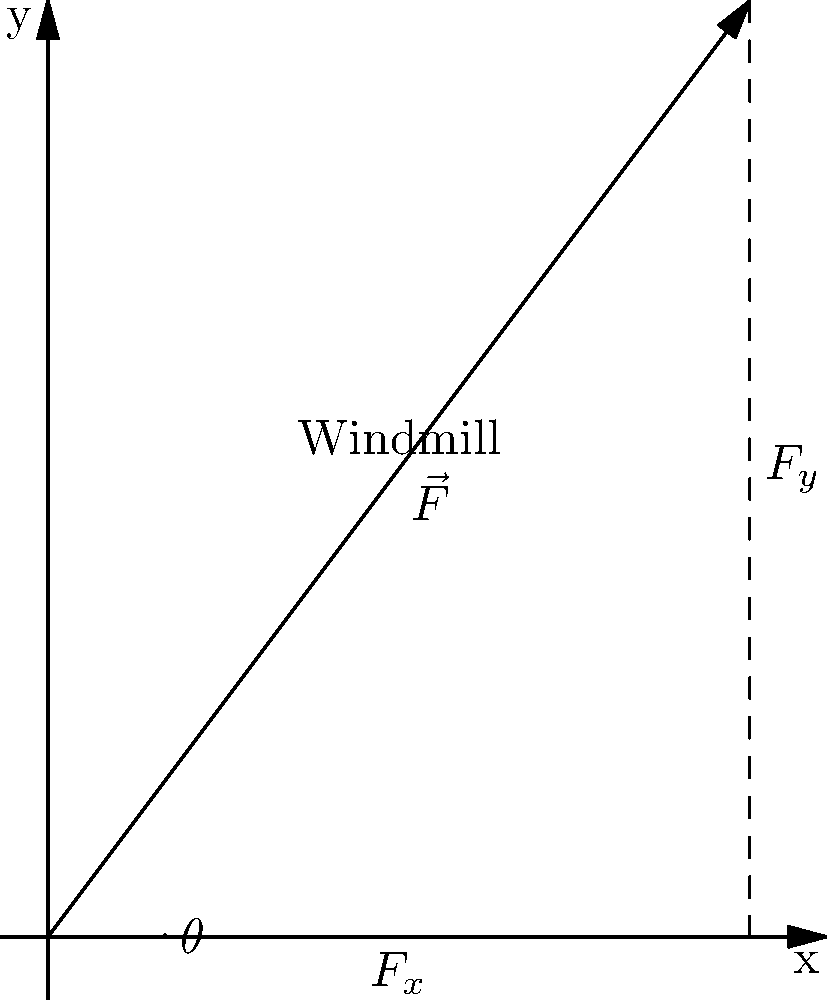In our historic Scanian windmill, the wind exerts a force $\vec{F}$ on the sails with a magnitude of 500 N at an angle of $53.13^\circ$ from the horizontal. What is the vertical component of this force, which contributes to the structural load on the windmill tower? To solve this problem, we'll use vector decomposition to find the vertical component of the force. Let's approach this step-by-step:

1) The force vector $\vec{F}$ can be decomposed into horizontal ($F_x$) and vertical ($F_y$) components.

2) We're interested in the vertical component $F_y$, which can be calculated using trigonometry:

   $F_y = |\vec{F}| \sin(\theta)$

3) We're given:
   - Magnitude of force $|\vec{F}| = 500$ N
   - Angle $\theta = 53.13^\circ$

4) Let's substitute these values:

   $F_y = 500 \sin(53.13^\circ)$

5) Using a calculator (or trigonometric tables, as they might have used in historical times):

   $\sin(53.13^\circ) \approx 0.8$

6) Therefore:

   $F_y = 500 \times 0.8 = 400$ N

So, the vertical component of the force, which contributes to the structural load on the windmill tower, is approximately 400 N.
Answer: 400 N 